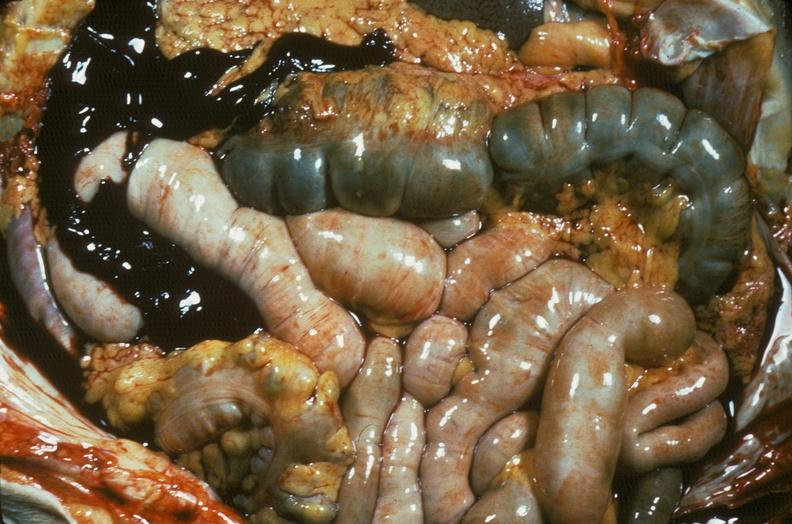what does this image show?
Answer the question using a single word or phrase. Hemorrhage secondary to ruptured aneurysm 